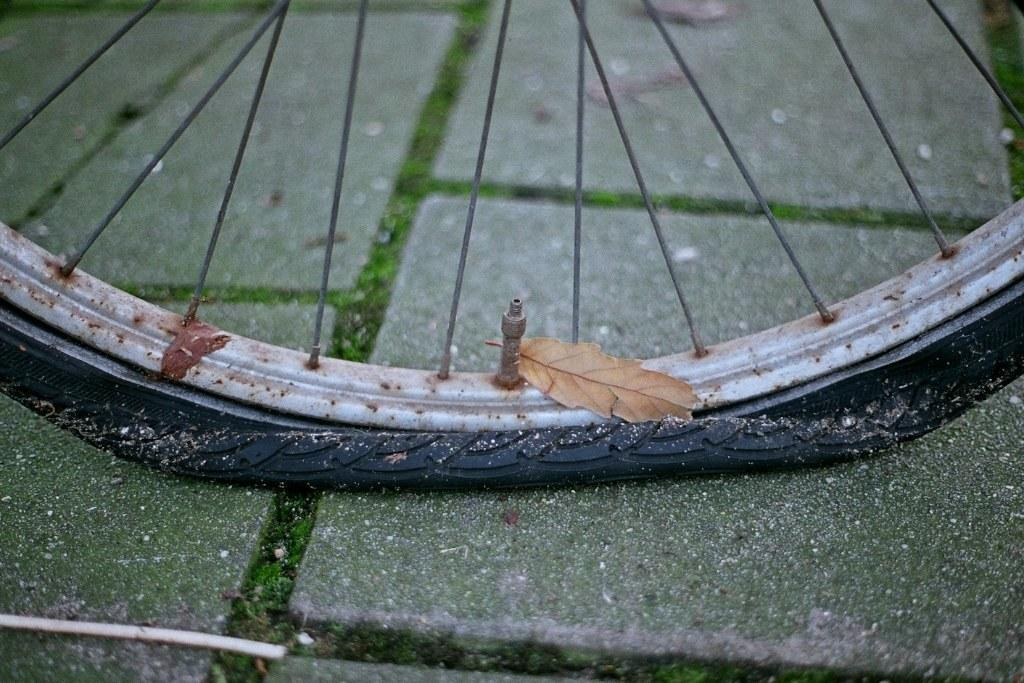What object can be seen on the ground in the image? There is a wheel on the ground in the image. What else is present in the image besides the wheel? There is a dried leaf in the image. Where is the parcel placed in the image? There is no parcel present in the image. What type of clothing is hanging from the wheel in the image? There is no clothing, such as a skirt, present in the image. 